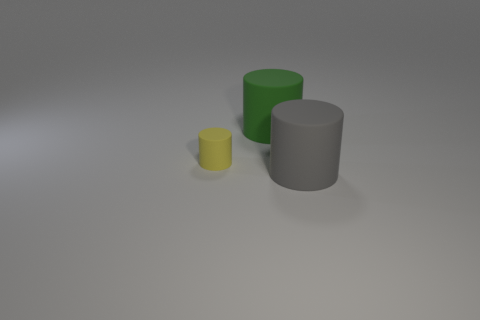What number of cylinders are the same material as the big gray object? 2 